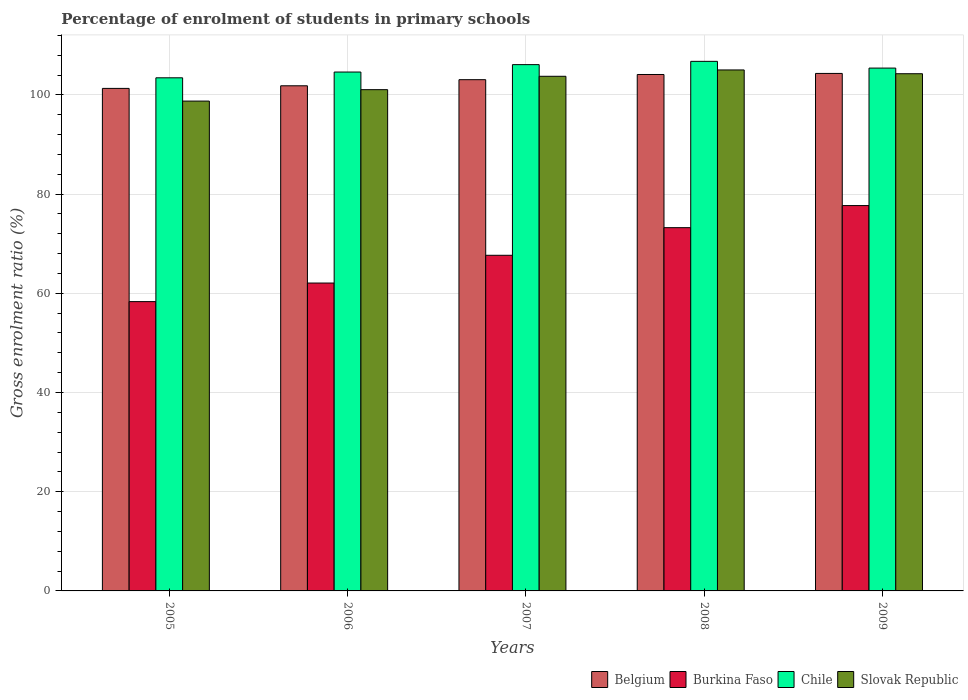What is the label of the 2nd group of bars from the left?
Offer a terse response. 2006. In how many cases, is the number of bars for a given year not equal to the number of legend labels?
Ensure brevity in your answer.  0. What is the percentage of students enrolled in primary schools in Slovak Republic in 2006?
Offer a very short reply. 101.05. Across all years, what is the maximum percentage of students enrolled in primary schools in Slovak Republic?
Your response must be concise. 105.02. Across all years, what is the minimum percentage of students enrolled in primary schools in Belgium?
Your answer should be very brief. 101.3. In which year was the percentage of students enrolled in primary schools in Slovak Republic maximum?
Ensure brevity in your answer.  2008. In which year was the percentage of students enrolled in primary schools in Burkina Faso minimum?
Offer a terse response. 2005. What is the total percentage of students enrolled in primary schools in Slovak Republic in the graph?
Make the answer very short. 512.82. What is the difference between the percentage of students enrolled in primary schools in Chile in 2005 and that in 2006?
Keep it short and to the point. -1.16. What is the difference between the percentage of students enrolled in primary schools in Burkina Faso in 2007 and the percentage of students enrolled in primary schools in Chile in 2006?
Offer a terse response. -36.94. What is the average percentage of students enrolled in primary schools in Chile per year?
Offer a very short reply. 105.26. In the year 2007, what is the difference between the percentage of students enrolled in primary schools in Burkina Faso and percentage of students enrolled in primary schools in Belgium?
Keep it short and to the point. -35.4. In how many years, is the percentage of students enrolled in primary schools in Belgium greater than 44 %?
Make the answer very short. 5. What is the ratio of the percentage of students enrolled in primary schools in Slovak Republic in 2006 to that in 2008?
Provide a short and direct response. 0.96. Is the percentage of students enrolled in primary schools in Chile in 2008 less than that in 2009?
Keep it short and to the point. No. Is the difference between the percentage of students enrolled in primary schools in Burkina Faso in 2005 and 2006 greater than the difference between the percentage of students enrolled in primary schools in Belgium in 2005 and 2006?
Make the answer very short. No. What is the difference between the highest and the second highest percentage of students enrolled in primary schools in Chile?
Your response must be concise. 0.66. What is the difference between the highest and the lowest percentage of students enrolled in primary schools in Slovak Republic?
Make the answer very short. 6.28. Is the sum of the percentage of students enrolled in primary schools in Chile in 2008 and 2009 greater than the maximum percentage of students enrolled in primary schools in Slovak Republic across all years?
Offer a terse response. Yes. What does the 1st bar from the left in 2009 represents?
Ensure brevity in your answer.  Belgium. What does the 1st bar from the right in 2005 represents?
Give a very brief answer. Slovak Republic. Is it the case that in every year, the sum of the percentage of students enrolled in primary schools in Slovak Republic and percentage of students enrolled in primary schools in Chile is greater than the percentage of students enrolled in primary schools in Belgium?
Provide a succinct answer. Yes. How many bars are there?
Keep it short and to the point. 20. Are all the bars in the graph horizontal?
Provide a succinct answer. No. How many years are there in the graph?
Give a very brief answer. 5. Are the values on the major ticks of Y-axis written in scientific E-notation?
Offer a very short reply. No. Does the graph contain any zero values?
Keep it short and to the point. No. Where does the legend appear in the graph?
Ensure brevity in your answer.  Bottom right. How are the legend labels stacked?
Your response must be concise. Horizontal. What is the title of the graph?
Ensure brevity in your answer.  Percentage of enrolment of students in primary schools. What is the label or title of the X-axis?
Offer a very short reply. Years. What is the Gross enrolment ratio (%) in Belgium in 2005?
Give a very brief answer. 101.3. What is the Gross enrolment ratio (%) of Burkina Faso in 2005?
Offer a very short reply. 58.32. What is the Gross enrolment ratio (%) of Chile in 2005?
Give a very brief answer. 103.44. What is the Gross enrolment ratio (%) of Slovak Republic in 2005?
Your answer should be very brief. 98.75. What is the Gross enrolment ratio (%) in Belgium in 2006?
Your answer should be compact. 101.83. What is the Gross enrolment ratio (%) of Burkina Faso in 2006?
Offer a terse response. 62.07. What is the Gross enrolment ratio (%) in Chile in 2006?
Offer a terse response. 104.6. What is the Gross enrolment ratio (%) of Slovak Republic in 2006?
Keep it short and to the point. 101.05. What is the Gross enrolment ratio (%) in Belgium in 2007?
Give a very brief answer. 103.06. What is the Gross enrolment ratio (%) in Burkina Faso in 2007?
Offer a very short reply. 67.66. What is the Gross enrolment ratio (%) in Chile in 2007?
Provide a short and direct response. 106.09. What is the Gross enrolment ratio (%) in Slovak Republic in 2007?
Your response must be concise. 103.74. What is the Gross enrolment ratio (%) of Belgium in 2008?
Your answer should be very brief. 104.1. What is the Gross enrolment ratio (%) in Burkina Faso in 2008?
Your response must be concise. 73.23. What is the Gross enrolment ratio (%) of Chile in 2008?
Provide a short and direct response. 106.75. What is the Gross enrolment ratio (%) of Slovak Republic in 2008?
Provide a succinct answer. 105.02. What is the Gross enrolment ratio (%) in Belgium in 2009?
Provide a succinct answer. 104.32. What is the Gross enrolment ratio (%) in Burkina Faso in 2009?
Provide a short and direct response. 77.68. What is the Gross enrolment ratio (%) of Chile in 2009?
Make the answer very short. 105.4. What is the Gross enrolment ratio (%) of Slovak Republic in 2009?
Offer a very short reply. 104.26. Across all years, what is the maximum Gross enrolment ratio (%) in Belgium?
Offer a very short reply. 104.32. Across all years, what is the maximum Gross enrolment ratio (%) of Burkina Faso?
Give a very brief answer. 77.68. Across all years, what is the maximum Gross enrolment ratio (%) of Chile?
Provide a succinct answer. 106.75. Across all years, what is the maximum Gross enrolment ratio (%) in Slovak Republic?
Provide a succinct answer. 105.02. Across all years, what is the minimum Gross enrolment ratio (%) in Belgium?
Ensure brevity in your answer.  101.3. Across all years, what is the minimum Gross enrolment ratio (%) in Burkina Faso?
Provide a short and direct response. 58.32. Across all years, what is the minimum Gross enrolment ratio (%) in Chile?
Offer a terse response. 103.44. Across all years, what is the minimum Gross enrolment ratio (%) in Slovak Republic?
Offer a terse response. 98.75. What is the total Gross enrolment ratio (%) of Belgium in the graph?
Offer a terse response. 514.62. What is the total Gross enrolment ratio (%) of Burkina Faso in the graph?
Provide a succinct answer. 338.95. What is the total Gross enrolment ratio (%) in Chile in the graph?
Make the answer very short. 526.28. What is the total Gross enrolment ratio (%) of Slovak Republic in the graph?
Provide a short and direct response. 512.82. What is the difference between the Gross enrolment ratio (%) in Belgium in 2005 and that in 2006?
Ensure brevity in your answer.  -0.53. What is the difference between the Gross enrolment ratio (%) of Burkina Faso in 2005 and that in 2006?
Provide a short and direct response. -3.74. What is the difference between the Gross enrolment ratio (%) of Chile in 2005 and that in 2006?
Ensure brevity in your answer.  -1.16. What is the difference between the Gross enrolment ratio (%) in Slovak Republic in 2005 and that in 2006?
Make the answer very short. -2.3. What is the difference between the Gross enrolment ratio (%) in Belgium in 2005 and that in 2007?
Provide a succinct answer. -1.76. What is the difference between the Gross enrolment ratio (%) in Burkina Faso in 2005 and that in 2007?
Provide a short and direct response. -9.34. What is the difference between the Gross enrolment ratio (%) of Chile in 2005 and that in 2007?
Provide a succinct answer. -2.65. What is the difference between the Gross enrolment ratio (%) of Slovak Republic in 2005 and that in 2007?
Ensure brevity in your answer.  -5. What is the difference between the Gross enrolment ratio (%) of Belgium in 2005 and that in 2008?
Offer a very short reply. -2.8. What is the difference between the Gross enrolment ratio (%) in Burkina Faso in 2005 and that in 2008?
Provide a short and direct response. -14.91. What is the difference between the Gross enrolment ratio (%) of Chile in 2005 and that in 2008?
Your response must be concise. -3.32. What is the difference between the Gross enrolment ratio (%) of Slovak Republic in 2005 and that in 2008?
Ensure brevity in your answer.  -6.28. What is the difference between the Gross enrolment ratio (%) of Belgium in 2005 and that in 2009?
Make the answer very short. -3.02. What is the difference between the Gross enrolment ratio (%) in Burkina Faso in 2005 and that in 2009?
Provide a short and direct response. -19.36. What is the difference between the Gross enrolment ratio (%) in Chile in 2005 and that in 2009?
Provide a succinct answer. -1.96. What is the difference between the Gross enrolment ratio (%) of Slovak Republic in 2005 and that in 2009?
Make the answer very short. -5.52. What is the difference between the Gross enrolment ratio (%) in Belgium in 2006 and that in 2007?
Your answer should be very brief. -1.23. What is the difference between the Gross enrolment ratio (%) in Burkina Faso in 2006 and that in 2007?
Ensure brevity in your answer.  -5.59. What is the difference between the Gross enrolment ratio (%) in Chile in 2006 and that in 2007?
Your answer should be compact. -1.49. What is the difference between the Gross enrolment ratio (%) of Slovak Republic in 2006 and that in 2007?
Offer a terse response. -2.7. What is the difference between the Gross enrolment ratio (%) in Belgium in 2006 and that in 2008?
Your response must be concise. -2.27. What is the difference between the Gross enrolment ratio (%) in Burkina Faso in 2006 and that in 2008?
Offer a terse response. -11.16. What is the difference between the Gross enrolment ratio (%) of Chile in 2006 and that in 2008?
Provide a succinct answer. -2.15. What is the difference between the Gross enrolment ratio (%) of Slovak Republic in 2006 and that in 2008?
Make the answer very short. -3.98. What is the difference between the Gross enrolment ratio (%) of Belgium in 2006 and that in 2009?
Offer a terse response. -2.49. What is the difference between the Gross enrolment ratio (%) of Burkina Faso in 2006 and that in 2009?
Provide a short and direct response. -15.62. What is the difference between the Gross enrolment ratio (%) of Chile in 2006 and that in 2009?
Your response must be concise. -0.8. What is the difference between the Gross enrolment ratio (%) of Slovak Republic in 2006 and that in 2009?
Provide a short and direct response. -3.21. What is the difference between the Gross enrolment ratio (%) in Belgium in 2007 and that in 2008?
Your answer should be compact. -1.04. What is the difference between the Gross enrolment ratio (%) of Burkina Faso in 2007 and that in 2008?
Your response must be concise. -5.57. What is the difference between the Gross enrolment ratio (%) in Chile in 2007 and that in 2008?
Make the answer very short. -0.66. What is the difference between the Gross enrolment ratio (%) of Slovak Republic in 2007 and that in 2008?
Provide a succinct answer. -1.28. What is the difference between the Gross enrolment ratio (%) of Belgium in 2007 and that in 2009?
Keep it short and to the point. -1.26. What is the difference between the Gross enrolment ratio (%) in Burkina Faso in 2007 and that in 2009?
Provide a short and direct response. -10.02. What is the difference between the Gross enrolment ratio (%) of Chile in 2007 and that in 2009?
Make the answer very short. 0.69. What is the difference between the Gross enrolment ratio (%) of Slovak Republic in 2007 and that in 2009?
Provide a short and direct response. -0.52. What is the difference between the Gross enrolment ratio (%) in Belgium in 2008 and that in 2009?
Offer a very short reply. -0.22. What is the difference between the Gross enrolment ratio (%) of Burkina Faso in 2008 and that in 2009?
Make the answer very short. -4.45. What is the difference between the Gross enrolment ratio (%) of Chile in 2008 and that in 2009?
Make the answer very short. 1.36. What is the difference between the Gross enrolment ratio (%) in Slovak Republic in 2008 and that in 2009?
Make the answer very short. 0.76. What is the difference between the Gross enrolment ratio (%) in Belgium in 2005 and the Gross enrolment ratio (%) in Burkina Faso in 2006?
Keep it short and to the point. 39.24. What is the difference between the Gross enrolment ratio (%) in Belgium in 2005 and the Gross enrolment ratio (%) in Chile in 2006?
Your answer should be very brief. -3.3. What is the difference between the Gross enrolment ratio (%) of Belgium in 2005 and the Gross enrolment ratio (%) of Slovak Republic in 2006?
Provide a short and direct response. 0.25. What is the difference between the Gross enrolment ratio (%) of Burkina Faso in 2005 and the Gross enrolment ratio (%) of Chile in 2006?
Keep it short and to the point. -46.28. What is the difference between the Gross enrolment ratio (%) of Burkina Faso in 2005 and the Gross enrolment ratio (%) of Slovak Republic in 2006?
Make the answer very short. -42.73. What is the difference between the Gross enrolment ratio (%) of Chile in 2005 and the Gross enrolment ratio (%) of Slovak Republic in 2006?
Provide a succinct answer. 2.39. What is the difference between the Gross enrolment ratio (%) of Belgium in 2005 and the Gross enrolment ratio (%) of Burkina Faso in 2007?
Keep it short and to the point. 33.64. What is the difference between the Gross enrolment ratio (%) in Belgium in 2005 and the Gross enrolment ratio (%) in Chile in 2007?
Provide a succinct answer. -4.79. What is the difference between the Gross enrolment ratio (%) of Belgium in 2005 and the Gross enrolment ratio (%) of Slovak Republic in 2007?
Make the answer very short. -2.44. What is the difference between the Gross enrolment ratio (%) in Burkina Faso in 2005 and the Gross enrolment ratio (%) in Chile in 2007?
Provide a succinct answer. -47.77. What is the difference between the Gross enrolment ratio (%) in Burkina Faso in 2005 and the Gross enrolment ratio (%) in Slovak Republic in 2007?
Provide a short and direct response. -45.42. What is the difference between the Gross enrolment ratio (%) in Chile in 2005 and the Gross enrolment ratio (%) in Slovak Republic in 2007?
Provide a short and direct response. -0.31. What is the difference between the Gross enrolment ratio (%) in Belgium in 2005 and the Gross enrolment ratio (%) in Burkina Faso in 2008?
Provide a short and direct response. 28.07. What is the difference between the Gross enrolment ratio (%) in Belgium in 2005 and the Gross enrolment ratio (%) in Chile in 2008?
Offer a terse response. -5.45. What is the difference between the Gross enrolment ratio (%) in Belgium in 2005 and the Gross enrolment ratio (%) in Slovak Republic in 2008?
Your answer should be very brief. -3.72. What is the difference between the Gross enrolment ratio (%) in Burkina Faso in 2005 and the Gross enrolment ratio (%) in Chile in 2008?
Your answer should be compact. -48.43. What is the difference between the Gross enrolment ratio (%) in Burkina Faso in 2005 and the Gross enrolment ratio (%) in Slovak Republic in 2008?
Offer a terse response. -46.7. What is the difference between the Gross enrolment ratio (%) in Chile in 2005 and the Gross enrolment ratio (%) in Slovak Republic in 2008?
Your response must be concise. -1.59. What is the difference between the Gross enrolment ratio (%) of Belgium in 2005 and the Gross enrolment ratio (%) of Burkina Faso in 2009?
Make the answer very short. 23.62. What is the difference between the Gross enrolment ratio (%) of Belgium in 2005 and the Gross enrolment ratio (%) of Chile in 2009?
Your answer should be very brief. -4.1. What is the difference between the Gross enrolment ratio (%) of Belgium in 2005 and the Gross enrolment ratio (%) of Slovak Republic in 2009?
Your response must be concise. -2.96. What is the difference between the Gross enrolment ratio (%) in Burkina Faso in 2005 and the Gross enrolment ratio (%) in Chile in 2009?
Keep it short and to the point. -47.08. What is the difference between the Gross enrolment ratio (%) of Burkina Faso in 2005 and the Gross enrolment ratio (%) of Slovak Republic in 2009?
Ensure brevity in your answer.  -45.94. What is the difference between the Gross enrolment ratio (%) in Chile in 2005 and the Gross enrolment ratio (%) in Slovak Republic in 2009?
Give a very brief answer. -0.82. What is the difference between the Gross enrolment ratio (%) in Belgium in 2006 and the Gross enrolment ratio (%) in Burkina Faso in 2007?
Your response must be concise. 34.17. What is the difference between the Gross enrolment ratio (%) of Belgium in 2006 and the Gross enrolment ratio (%) of Chile in 2007?
Your answer should be compact. -4.26. What is the difference between the Gross enrolment ratio (%) in Belgium in 2006 and the Gross enrolment ratio (%) in Slovak Republic in 2007?
Give a very brief answer. -1.91. What is the difference between the Gross enrolment ratio (%) in Burkina Faso in 2006 and the Gross enrolment ratio (%) in Chile in 2007?
Provide a short and direct response. -44.03. What is the difference between the Gross enrolment ratio (%) in Burkina Faso in 2006 and the Gross enrolment ratio (%) in Slovak Republic in 2007?
Provide a short and direct response. -41.68. What is the difference between the Gross enrolment ratio (%) of Chile in 2006 and the Gross enrolment ratio (%) of Slovak Republic in 2007?
Provide a short and direct response. 0.86. What is the difference between the Gross enrolment ratio (%) of Belgium in 2006 and the Gross enrolment ratio (%) of Burkina Faso in 2008?
Keep it short and to the point. 28.6. What is the difference between the Gross enrolment ratio (%) of Belgium in 2006 and the Gross enrolment ratio (%) of Chile in 2008?
Provide a succinct answer. -4.92. What is the difference between the Gross enrolment ratio (%) in Belgium in 2006 and the Gross enrolment ratio (%) in Slovak Republic in 2008?
Keep it short and to the point. -3.19. What is the difference between the Gross enrolment ratio (%) in Burkina Faso in 2006 and the Gross enrolment ratio (%) in Chile in 2008?
Provide a succinct answer. -44.69. What is the difference between the Gross enrolment ratio (%) in Burkina Faso in 2006 and the Gross enrolment ratio (%) in Slovak Republic in 2008?
Offer a very short reply. -42.96. What is the difference between the Gross enrolment ratio (%) of Chile in 2006 and the Gross enrolment ratio (%) of Slovak Republic in 2008?
Give a very brief answer. -0.42. What is the difference between the Gross enrolment ratio (%) in Belgium in 2006 and the Gross enrolment ratio (%) in Burkina Faso in 2009?
Keep it short and to the point. 24.15. What is the difference between the Gross enrolment ratio (%) in Belgium in 2006 and the Gross enrolment ratio (%) in Chile in 2009?
Offer a terse response. -3.57. What is the difference between the Gross enrolment ratio (%) of Belgium in 2006 and the Gross enrolment ratio (%) of Slovak Republic in 2009?
Offer a very short reply. -2.43. What is the difference between the Gross enrolment ratio (%) of Burkina Faso in 2006 and the Gross enrolment ratio (%) of Chile in 2009?
Offer a terse response. -43.33. What is the difference between the Gross enrolment ratio (%) in Burkina Faso in 2006 and the Gross enrolment ratio (%) in Slovak Republic in 2009?
Give a very brief answer. -42.2. What is the difference between the Gross enrolment ratio (%) of Chile in 2006 and the Gross enrolment ratio (%) of Slovak Republic in 2009?
Offer a terse response. 0.34. What is the difference between the Gross enrolment ratio (%) of Belgium in 2007 and the Gross enrolment ratio (%) of Burkina Faso in 2008?
Your answer should be very brief. 29.83. What is the difference between the Gross enrolment ratio (%) in Belgium in 2007 and the Gross enrolment ratio (%) in Chile in 2008?
Your answer should be very brief. -3.7. What is the difference between the Gross enrolment ratio (%) in Belgium in 2007 and the Gross enrolment ratio (%) in Slovak Republic in 2008?
Provide a succinct answer. -1.96. What is the difference between the Gross enrolment ratio (%) in Burkina Faso in 2007 and the Gross enrolment ratio (%) in Chile in 2008?
Your answer should be compact. -39.09. What is the difference between the Gross enrolment ratio (%) of Burkina Faso in 2007 and the Gross enrolment ratio (%) of Slovak Republic in 2008?
Provide a succinct answer. -37.36. What is the difference between the Gross enrolment ratio (%) of Chile in 2007 and the Gross enrolment ratio (%) of Slovak Republic in 2008?
Give a very brief answer. 1.07. What is the difference between the Gross enrolment ratio (%) of Belgium in 2007 and the Gross enrolment ratio (%) of Burkina Faso in 2009?
Offer a terse response. 25.38. What is the difference between the Gross enrolment ratio (%) of Belgium in 2007 and the Gross enrolment ratio (%) of Chile in 2009?
Make the answer very short. -2.34. What is the difference between the Gross enrolment ratio (%) of Belgium in 2007 and the Gross enrolment ratio (%) of Slovak Republic in 2009?
Your response must be concise. -1.2. What is the difference between the Gross enrolment ratio (%) of Burkina Faso in 2007 and the Gross enrolment ratio (%) of Chile in 2009?
Offer a terse response. -37.74. What is the difference between the Gross enrolment ratio (%) in Burkina Faso in 2007 and the Gross enrolment ratio (%) in Slovak Republic in 2009?
Offer a terse response. -36.6. What is the difference between the Gross enrolment ratio (%) of Chile in 2007 and the Gross enrolment ratio (%) of Slovak Republic in 2009?
Your answer should be very brief. 1.83. What is the difference between the Gross enrolment ratio (%) in Belgium in 2008 and the Gross enrolment ratio (%) in Burkina Faso in 2009?
Your answer should be compact. 26.42. What is the difference between the Gross enrolment ratio (%) in Belgium in 2008 and the Gross enrolment ratio (%) in Chile in 2009?
Keep it short and to the point. -1.29. What is the difference between the Gross enrolment ratio (%) in Belgium in 2008 and the Gross enrolment ratio (%) in Slovak Republic in 2009?
Offer a terse response. -0.16. What is the difference between the Gross enrolment ratio (%) of Burkina Faso in 2008 and the Gross enrolment ratio (%) of Chile in 2009?
Provide a succinct answer. -32.17. What is the difference between the Gross enrolment ratio (%) in Burkina Faso in 2008 and the Gross enrolment ratio (%) in Slovak Republic in 2009?
Your answer should be very brief. -31.03. What is the difference between the Gross enrolment ratio (%) of Chile in 2008 and the Gross enrolment ratio (%) of Slovak Republic in 2009?
Your answer should be compact. 2.49. What is the average Gross enrolment ratio (%) in Belgium per year?
Give a very brief answer. 102.92. What is the average Gross enrolment ratio (%) of Burkina Faso per year?
Offer a very short reply. 67.79. What is the average Gross enrolment ratio (%) of Chile per year?
Offer a terse response. 105.26. What is the average Gross enrolment ratio (%) in Slovak Republic per year?
Ensure brevity in your answer.  102.56. In the year 2005, what is the difference between the Gross enrolment ratio (%) of Belgium and Gross enrolment ratio (%) of Burkina Faso?
Give a very brief answer. 42.98. In the year 2005, what is the difference between the Gross enrolment ratio (%) in Belgium and Gross enrolment ratio (%) in Chile?
Your response must be concise. -2.14. In the year 2005, what is the difference between the Gross enrolment ratio (%) in Belgium and Gross enrolment ratio (%) in Slovak Republic?
Provide a succinct answer. 2.56. In the year 2005, what is the difference between the Gross enrolment ratio (%) in Burkina Faso and Gross enrolment ratio (%) in Chile?
Make the answer very short. -45.12. In the year 2005, what is the difference between the Gross enrolment ratio (%) of Burkina Faso and Gross enrolment ratio (%) of Slovak Republic?
Offer a terse response. -40.42. In the year 2005, what is the difference between the Gross enrolment ratio (%) of Chile and Gross enrolment ratio (%) of Slovak Republic?
Provide a succinct answer. 4.69. In the year 2006, what is the difference between the Gross enrolment ratio (%) in Belgium and Gross enrolment ratio (%) in Burkina Faso?
Provide a succinct answer. 39.76. In the year 2006, what is the difference between the Gross enrolment ratio (%) in Belgium and Gross enrolment ratio (%) in Chile?
Keep it short and to the point. -2.77. In the year 2006, what is the difference between the Gross enrolment ratio (%) in Belgium and Gross enrolment ratio (%) in Slovak Republic?
Make the answer very short. 0.78. In the year 2006, what is the difference between the Gross enrolment ratio (%) in Burkina Faso and Gross enrolment ratio (%) in Chile?
Give a very brief answer. -42.54. In the year 2006, what is the difference between the Gross enrolment ratio (%) in Burkina Faso and Gross enrolment ratio (%) in Slovak Republic?
Your answer should be very brief. -38.98. In the year 2006, what is the difference between the Gross enrolment ratio (%) of Chile and Gross enrolment ratio (%) of Slovak Republic?
Make the answer very short. 3.55. In the year 2007, what is the difference between the Gross enrolment ratio (%) in Belgium and Gross enrolment ratio (%) in Burkina Faso?
Make the answer very short. 35.4. In the year 2007, what is the difference between the Gross enrolment ratio (%) in Belgium and Gross enrolment ratio (%) in Chile?
Make the answer very short. -3.03. In the year 2007, what is the difference between the Gross enrolment ratio (%) in Belgium and Gross enrolment ratio (%) in Slovak Republic?
Your response must be concise. -0.68. In the year 2007, what is the difference between the Gross enrolment ratio (%) in Burkina Faso and Gross enrolment ratio (%) in Chile?
Your response must be concise. -38.43. In the year 2007, what is the difference between the Gross enrolment ratio (%) in Burkina Faso and Gross enrolment ratio (%) in Slovak Republic?
Your response must be concise. -36.08. In the year 2007, what is the difference between the Gross enrolment ratio (%) of Chile and Gross enrolment ratio (%) of Slovak Republic?
Give a very brief answer. 2.35. In the year 2008, what is the difference between the Gross enrolment ratio (%) in Belgium and Gross enrolment ratio (%) in Burkina Faso?
Your answer should be compact. 30.88. In the year 2008, what is the difference between the Gross enrolment ratio (%) in Belgium and Gross enrolment ratio (%) in Chile?
Keep it short and to the point. -2.65. In the year 2008, what is the difference between the Gross enrolment ratio (%) of Belgium and Gross enrolment ratio (%) of Slovak Republic?
Keep it short and to the point. -0.92. In the year 2008, what is the difference between the Gross enrolment ratio (%) of Burkina Faso and Gross enrolment ratio (%) of Chile?
Give a very brief answer. -33.53. In the year 2008, what is the difference between the Gross enrolment ratio (%) in Burkina Faso and Gross enrolment ratio (%) in Slovak Republic?
Keep it short and to the point. -31.8. In the year 2008, what is the difference between the Gross enrolment ratio (%) of Chile and Gross enrolment ratio (%) of Slovak Republic?
Provide a succinct answer. 1.73. In the year 2009, what is the difference between the Gross enrolment ratio (%) in Belgium and Gross enrolment ratio (%) in Burkina Faso?
Your response must be concise. 26.64. In the year 2009, what is the difference between the Gross enrolment ratio (%) in Belgium and Gross enrolment ratio (%) in Chile?
Give a very brief answer. -1.08. In the year 2009, what is the difference between the Gross enrolment ratio (%) in Belgium and Gross enrolment ratio (%) in Slovak Republic?
Your answer should be compact. 0.06. In the year 2009, what is the difference between the Gross enrolment ratio (%) in Burkina Faso and Gross enrolment ratio (%) in Chile?
Keep it short and to the point. -27.72. In the year 2009, what is the difference between the Gross enrolment ratio (%) of Burkina Faso and Gross enrolment ratio (%) of Slovak Republic?
Provide a short and direct response. -26.58. In the year 2009, what is the difference between the Gross enrolment ratio (%) of Chile and Gross enrolment ratio (%) of Slovak Republic?
Offer a terse response. 1.14. What is the ratio of the Gross enrolment ratio (%) of Burkina Faso in 2005 to that in 2006?
Provide a succinct answer. 0.94. What is the ratio of the Gross enrolment ratio (%) in Chile in 2005 to that in 2006?
Your response must be concise. 0.99. What is the ratio of the Gross enrolment ratio (%) of Slovak Republic in 2005 to that in 2006?
Your answer should be compact. 0.98. What is the ratio of the Gross enrolment ratio (%) in Belgium in 2005 to that in 2007?
Offer a very short reply. 0.98. What is the ratio of the Gross enrolment ratio (%) of Burkina Faso in 2005 to that in 2007?
Make the answer very short. 0.86. What is the ratio of the Gross enrolment ratio (%) in Chile in 2005 to that in 2007?
Your response must be concise. 0.97. What is the ratio of the Gross enrolment ratio (%) of Slovak Republic in 2005 to that in 2007?
Offer a terse response. 0.95. What is the ratio of the Gross enrolment ratio (%) in Belgium in 2005 to that in 2008?
Your answer should be compact. 0.97. What is the ratio of the Gross enrolment ratio (%) of Burkina Faso in 2005 to that in 2008?
Give a very brief answer. 0.8. What is the ratio of the Gross enrolment ratio (%) in Chile in 2005 to that in 2008?
Keep it short and to the point. 0.97. What is the ratio of the Gross enrolment ratio (%) in Slovak Republic in 2005 to that in 2008?
Keep it short and to the point. 0.94. What is the ratio of the Gross enrolment ratio (%) of Belgium in 2005 to that in 2009?
Offer a terse response. 0.97. What is the ratio of the Gross enrolment ratio (%) in Burkina Faso in 2005 to that in 2009?
Your answer should be very brief. 0.75. What is the ratio of the Gross enrolment ratio (%) of Chile in 2005 to that in 2009?
Make the answer very short. 0.98. What is the ratio of the Gross enrolment ratio (%) of Slovak Republic in 2005 to that in 2009?
Your response must be concise. 0.95. What is the ratio of the Gross enrolment ratio (%) in Burkina Faso in 2006 to that in 2007?
Keep it short and to the point. 0.92. What is the ratio of the Gross enrolment ratio (%) in Chile in 2006 to that in 2007?
Offer a very short reply. 0.99. What is the ratio of the Gross enrolment ratio (%) in Belgium in 2006 to that in 2008?
Offer a terse response. 0.98. What is the ratio of the Gross enrolment ratio (%) in Burkina Faso in 2006 to that in 2008?
Offer a very short reply. 0.85. What is the ratio of the Gross enrolment ratio (%) of Chile in 2006 to that in 2008?
Ensure brevity in your answer.  0.98. What is the ratio of the Gross enrolment ratio (%) of Slovak Republic in 2006 to that in 2008?
Keep it short and to the point. 0.96. What is the ratio of the Gross enrolment ratio (%) of Belgium in 2006 to that in 2009?
Offer a very short reply. 0.98. What is the ratio of the Gross enrolment ratio (%) in Burkina Faso in 2006 to that in 2009?
Keep it short and to the point. 0.8. What is the ratio of the Gross enrolment ratio (%) of Chile in 2006 to that in 2009?
Keep it short and to the point. 0.99. What is the ratio of the Gross enrolment ratio (%) in Slovak Republic in 2006 to that in 2009?
Provide a short and direct response. 0.97. What is the ratio of the Gross enrolment ratio (%) in Belgium in 2007 to that in 2008?
Ensure brevity in your answer.  0.99. What is the ratio of the Gross enrolment ratio (%) of Burkina Faso in 2007 to that in 2008?
Your response must be concise. 0.92. What is the ratio of the Gross enrolment ratio (%) of Chile in 2007 to that in 2008?
Keep it short and to the point. 0.99. What is the ratio of the Gross enrolment ratio (%) in Slovak Republic in 2007 to that in 2008?
Your response must be concise. 0.99. What is the ratio of the Gross enrolment ratio (%) of Belgium in 2007 to that in 2009?
Offer a very short reply. 0.99. What is the ratio of the Gross enrolment ratio (%) in Burkina Faso in 2007 to that in 2009?
Give a very brief answer. 0.87. What is the ratio of the Gross enrolment ratio (%) in Chile in 2007 to that in 2009?
Your answer should be very brief. 1.01. What is the ratio of the Gross enrolment ratio (%) of Slovak Republic in 2007 to that in 2009?
Your answer should be very brief. 0.99. What is the ratio of the Gross enrolment ratio (%) of Burkina Faso in 2008 to that in 2009?
Provide a succinct answer. 0.94. What is the ratio of the Gross enrolment ratio (%) of Chile in 2008 to that in 2009?
Ensure brevity in your answer.  1.01. What is the ratio of the Gross enrolment ratio (%) in Slovak Republic in 2008 to that in 2009?
Your answer should be compact. 1.01. What is the difference between the highest and the second highest Gross enrolment ratio (%) in Belgium?
Provide a short and direct response. 0.22. What is the difference between the highest and the second highest Gross enrolment ratio (%) in Burkina Faso?
Give a very brief answer. 4.45. What is the difference between the highest and the second highest Gross enrolment ratio (%) of Chile?
Provide a succinct answer. 0.66. What is the difference between the highest and the second highest Gross enrolment ratio (%) of Slovak Republic?
Keep it short and to the point. 0.76. What is the difference between the highest and the lowest Gross enrolment ratio (%) of Belgium?
Ensure brevity in your answer.  3.02. What is the difference between the highest and the lowest Gross enrolment ratio (%) in Burkina Faso?
Keep it short and to the point. 19.36. What is the difference between the highest and the lowest Gross enrolment ratio (%) of Chile?
Provide a succinct answer. 3.32. What is the difference between the highest and the lowest Gross enrolment ratio (%) in Slovak Republic?
Your answer should be compact. 6.28. 